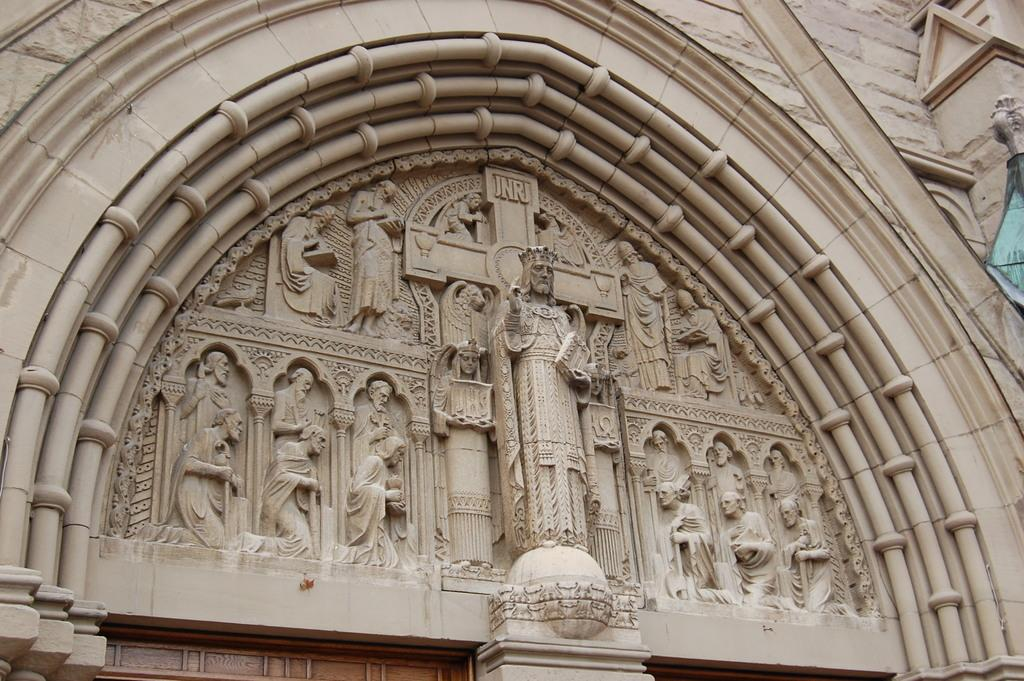What objects are present in the image? There are statues in the image. Where are the statues located? The statues are on the wall. How does the girl adjust the temperature of the statues in the image? There is no girl present in the image, and the statues do not have a temperature that can be adjusted. 